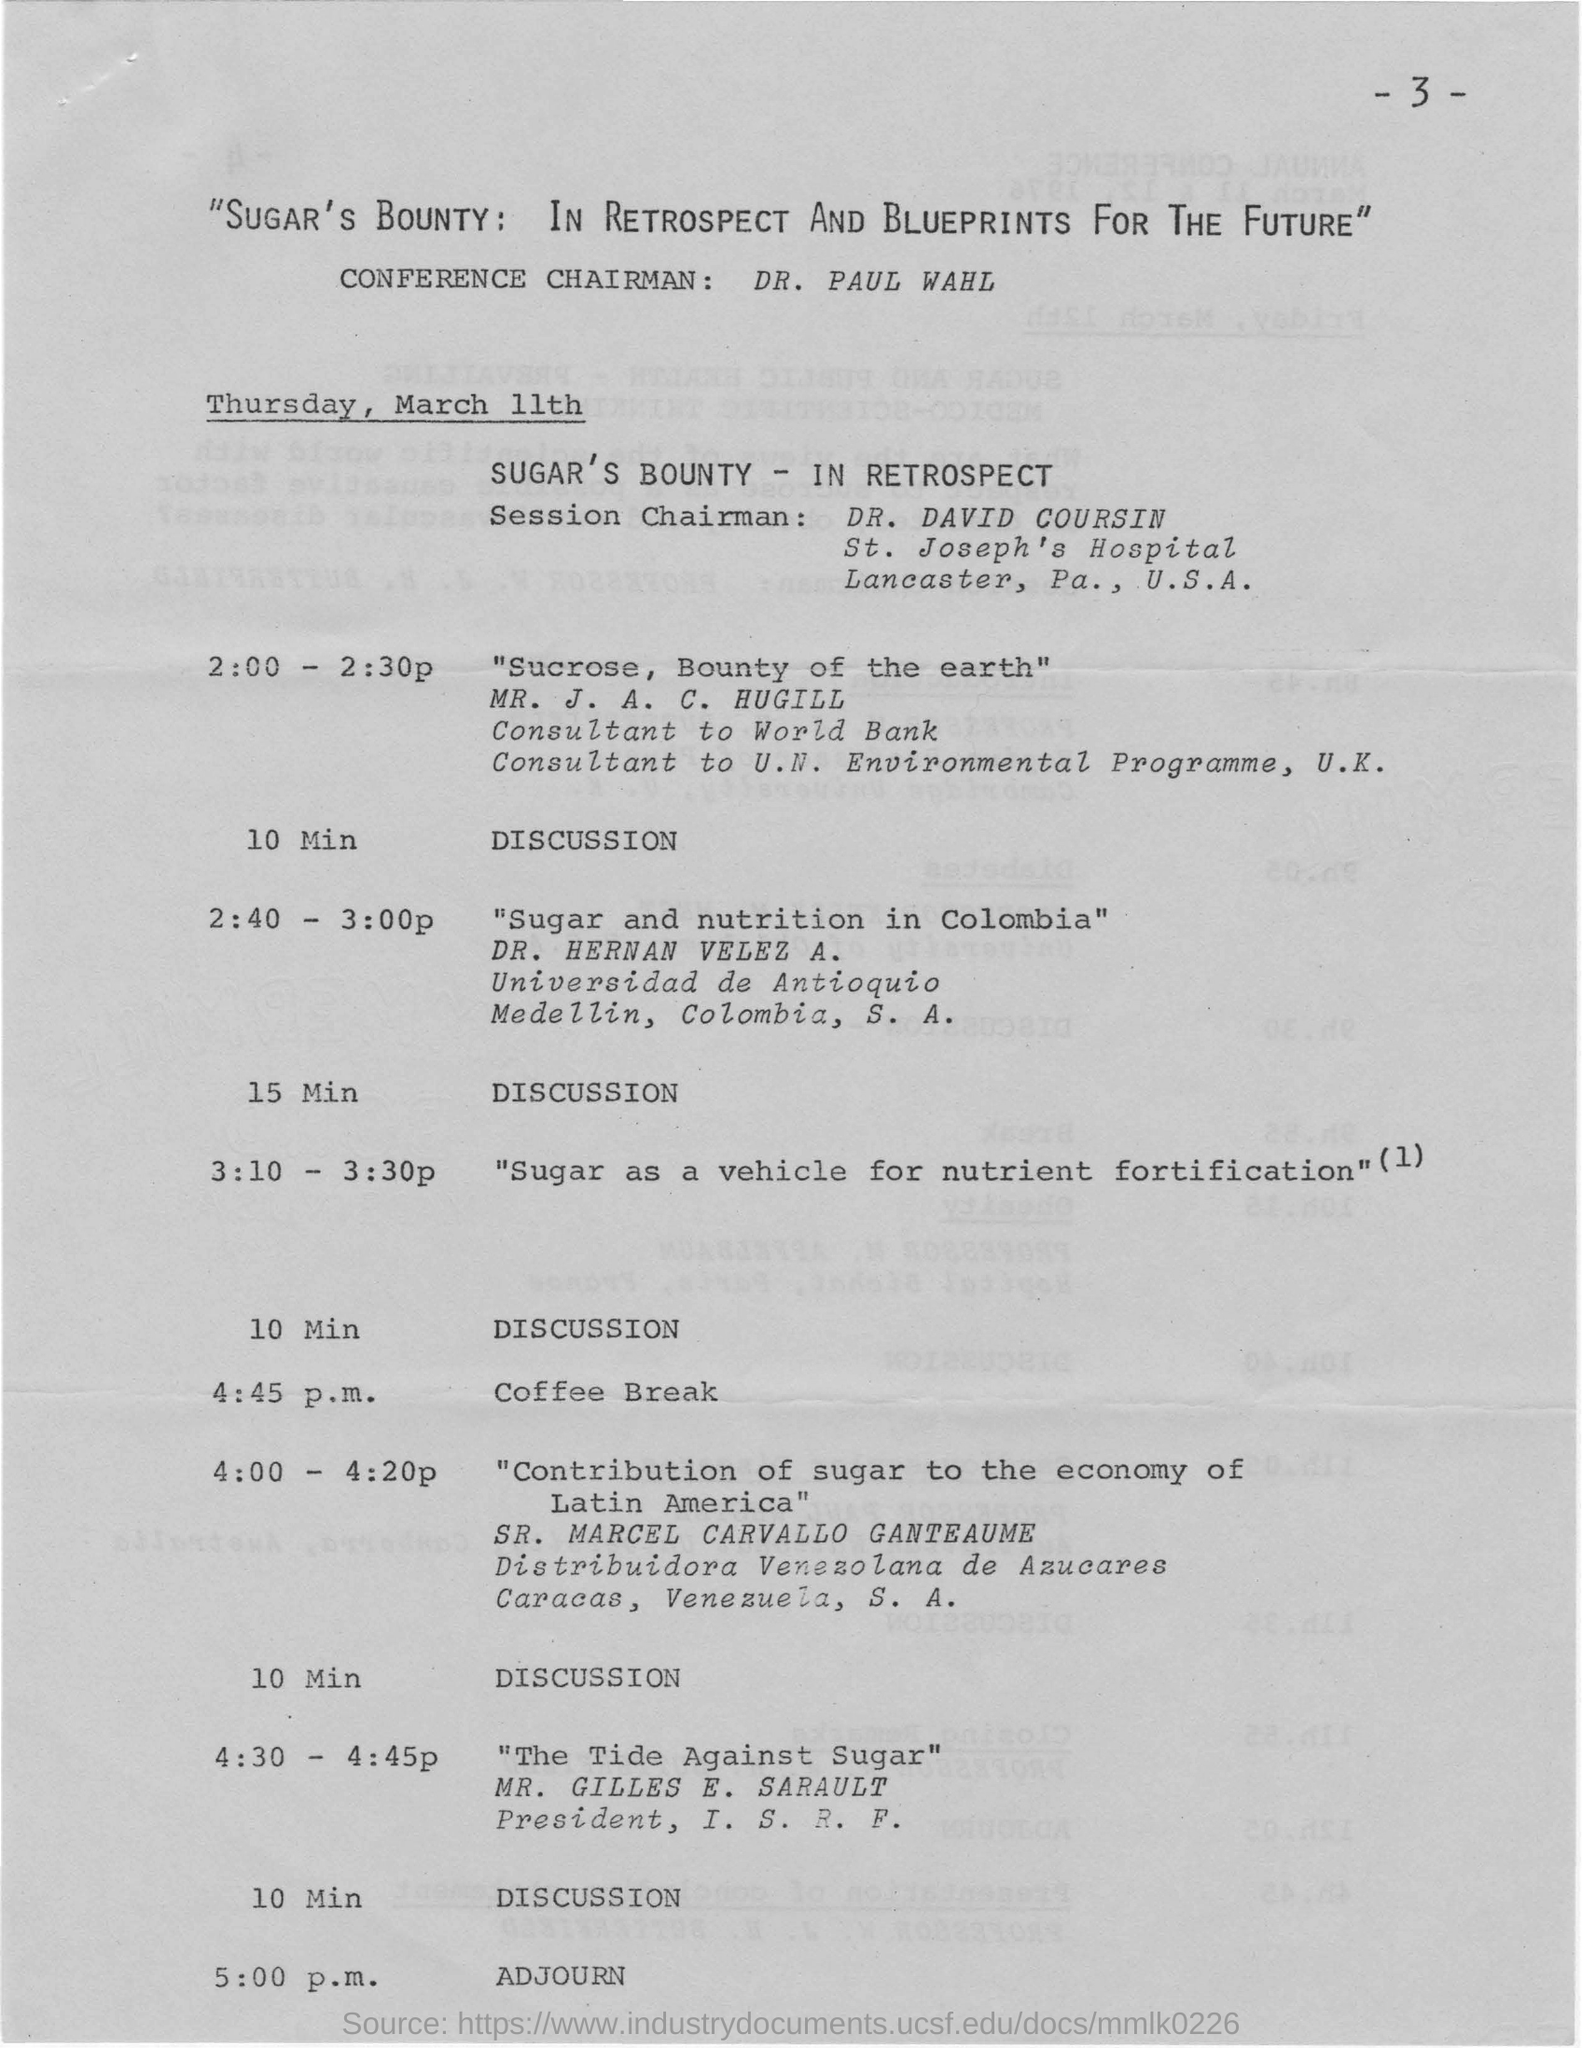Give some essential details in this illustration. The conference will be conducted on Thursday, March 11th. Dr. PAUL WAHL is the conference chairman. Dr. Hernan Velez discussed the topic of sugar and nutrition in Colombia. Dr. David Coursin is the Session Chairman. The coffee break is provided at 4:45 p.m. 